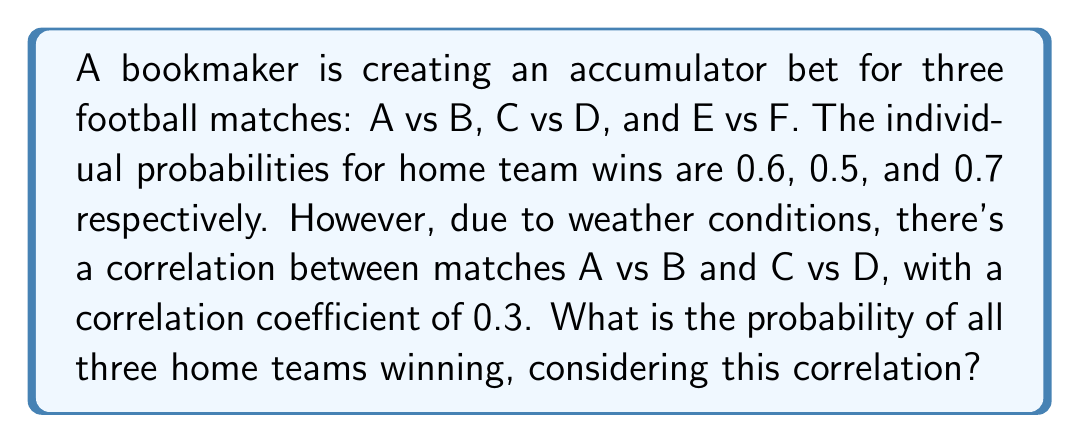Can you answer this question? Let's approach this step-by-step:

1) First, let's define our events:
   $P(A) = 0.6$ (probability of A winning)
   $P(C) = 0.5$ (probability of C winning)
   $P(E) = 0.7$ (probability of E winning)

2) For independent events, we would simply multiply the probabilities:
   $P(\text{all win}) = 0.6 \times 0.5 \times 0.7 = 0.21$

3) However, A and C are correlated. We need to use the formula for correlated events:

   $P(A \text{ and } C) = P(A)P(C) + \rho \sqrt{P(A)(1-P(A))P(C)(1-P(C))}$

   Where $\rho$ is the correlation coefficient (0.3 in this case)

4) Let's calculate:
   $P(A \text{ and } C) = 0.6 \times 0.5 + 0.3 \sqrt{0.6(1-0.6)0.5(1-0.5)}$
                       $= 0.3 + 0.3 \sqrt{0.24 \times 0.25}$
                       $= 0.3 + 0.3 \times 0.2449$
                       $= 0.3 + 0.07347$
                       $= 0.37347$

5) Now, we multiply this by the probability of E winning:
   $P(\text{all win}) = 0.37347 \times 0.7 = 0.261429$

Therefore, the probability of all three home teams winning, considering the correlation, is approximately 0.261429 or 26.14%.
Answer: 0.261429 